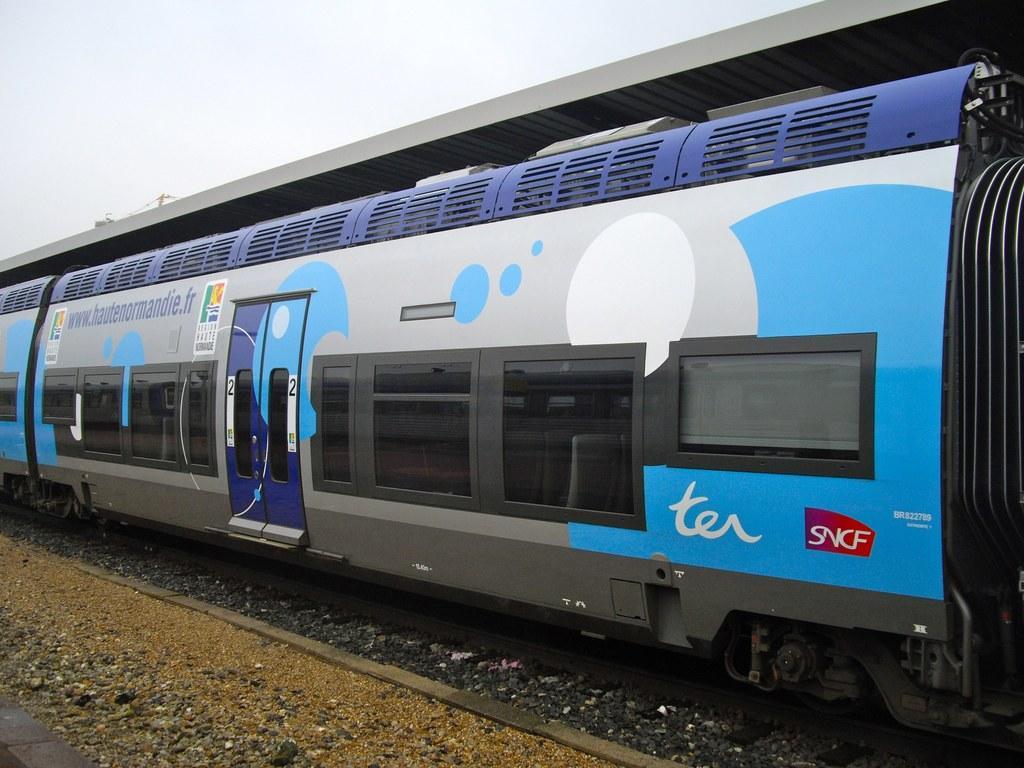Describe this image in one or two sentences. In this image, we can see a train with doors, windows, posters on the track. At the bottom, there is a ground. Top of the image, there is a sky. Through the glass we can see seat. 